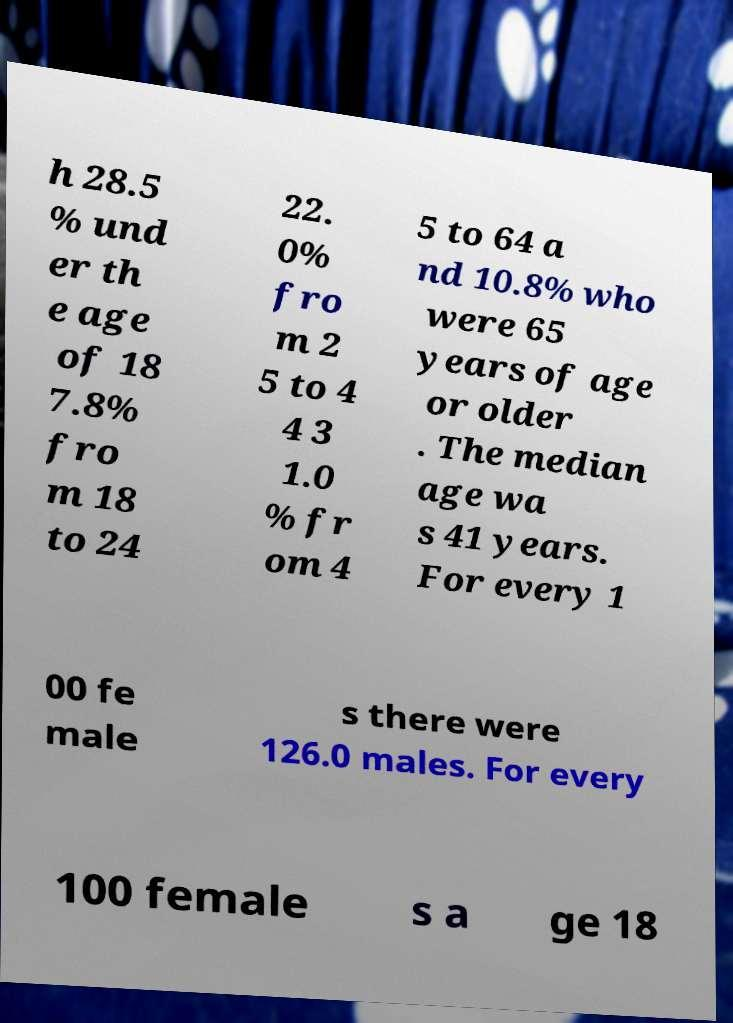Could you assist in decoding the text presented in this image and type it out clearly? h 28.5 % und er th e age of 18 7.8% fro m 18 to 24 22. 0% fro m 2 5 to 4 4 3 1.0 % fr om 4 5 to 64 a nd 10.8% who were 65 years of age or older . The median age wa s 41 years. For every 1 00 fe male s there were 126.0 males. For every 100 female s a ge 18 